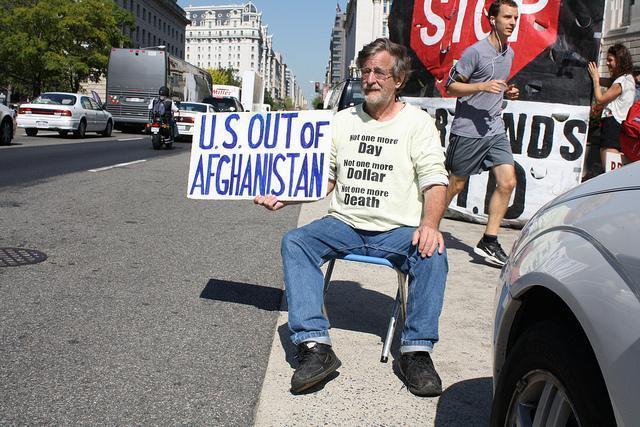How many people can be seen?
Give a very brief answer. 3. How many cars are there?
Give a very brief answer. 2. How many giraffes are shorter that the lamp post?
Give a very brief answer. 0. 